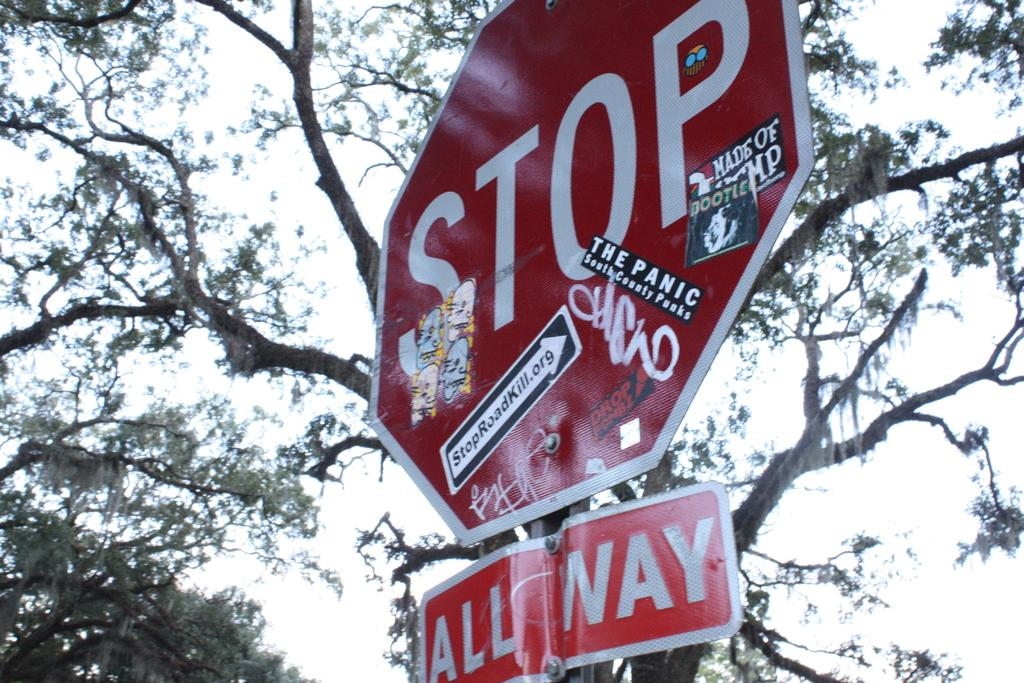<image>
Give a short and clear explanation of the subsequent image. An ALL WAY Stop sign with several stickers on it including one for StopRoadKill.org 